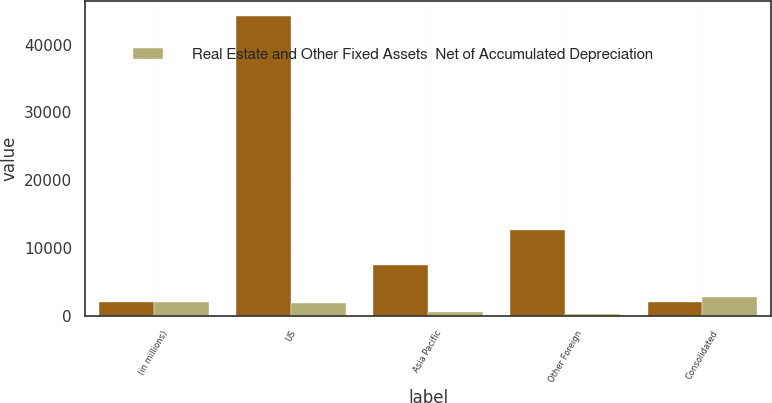<chart> <loc_0><loc_0><loc_500><loc_500><stacked_bar_chart><ecel><fcel>(in millions)<fcel>US<fcel>Asia Pacific<fcel>Other Foreign<fcel>Consolidated<nl><fcel>nan<fcel>2014<fcel>44274<fcel>7523<fcel>12609<fcel>2014<nl><fcel>Real Estate and Other Fixed Assets  Net of Accumulated Depreciation<fcel>2014<fcel>1886<fcel>521<fcel>293<fcel>2700<nl></chart> 